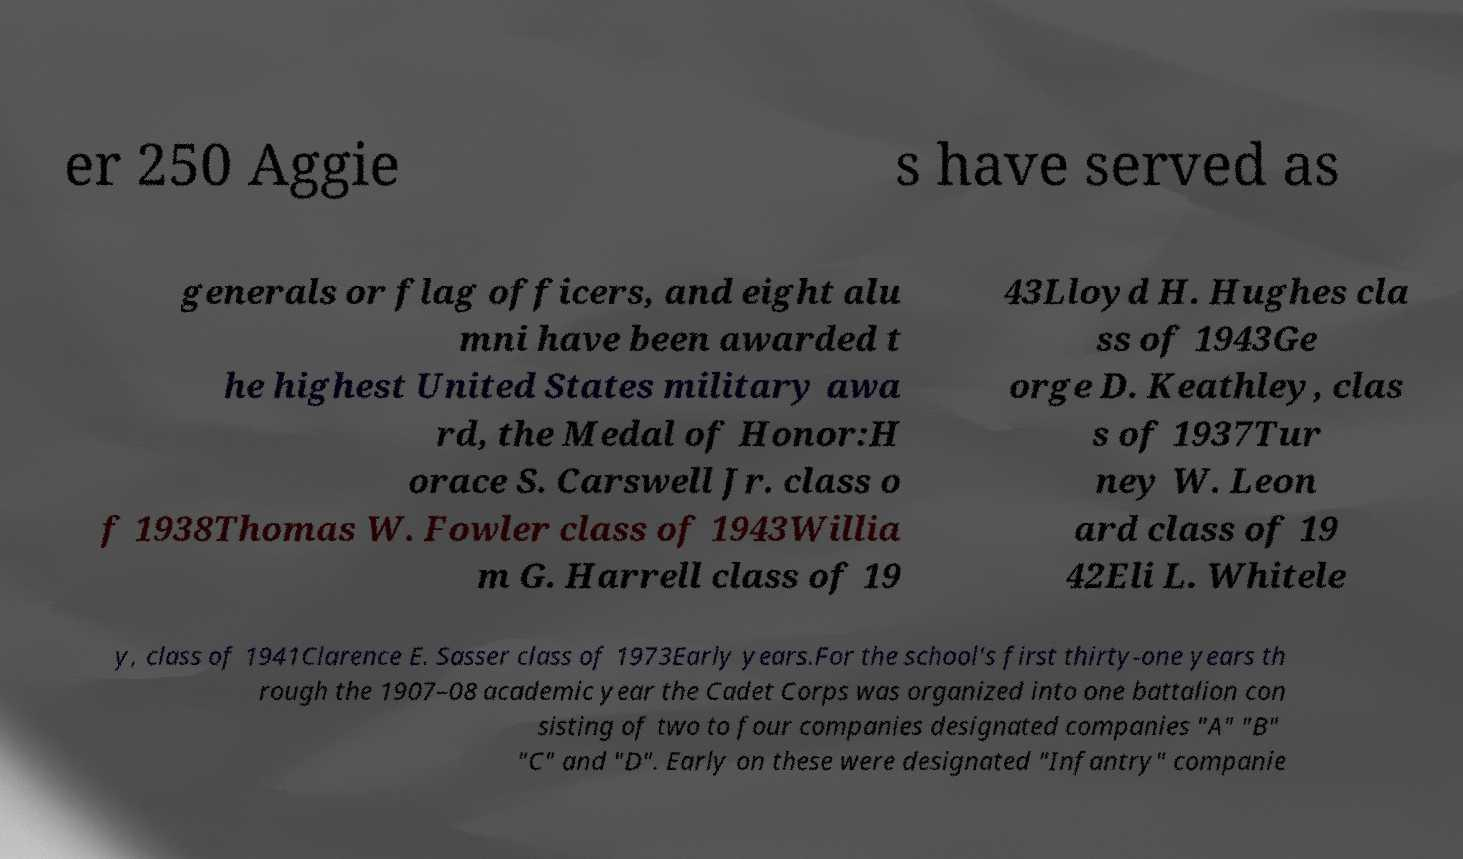I need the written content from this picture converted into text. Can you do that? er 250 Aggie s have served as generals or flag officers, and eight alu mni have been awarded t he highest United States military awa rd, the Medal of Honor:H orace S. Carswell Jr. class o f 1938Thomas W. Fowler class of 1943Willia m G. Harrell class of 19 43Lloyd H. Hughes cla ss of 1943Ge orge D. Keathley, clas s of 1937Tur ney W. Leon ard class of 19 42Eli L. Whitele y, class of 1941Clarence E. Sasser class of 1973Early years.For the school's first thirty-one years th rough the 1907–08 academic year the Cadet Corps was organized into one battalion con sisting of two to four companies designated companies "A" "B" "C" and "D". Early on these were designated "Infantry" companie 